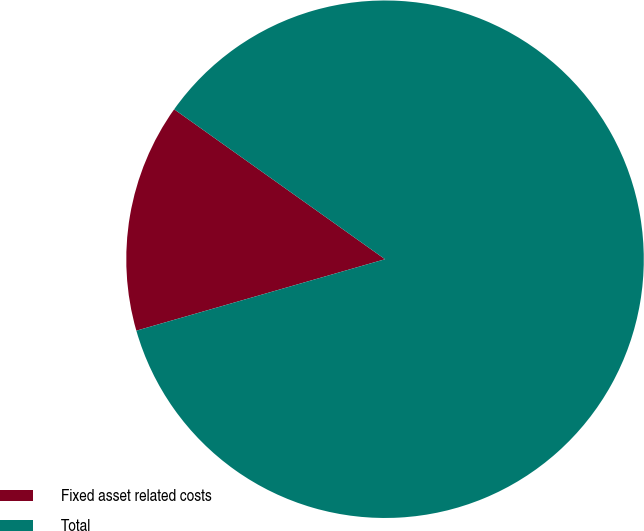<chart> <loc_0><loc_0><loc_500><loc_500><pie_chart><fcel>Fixed asset related costs<fcel>Total<nl><fcel>14.29%<fcel>85.71%<nl></chart> 